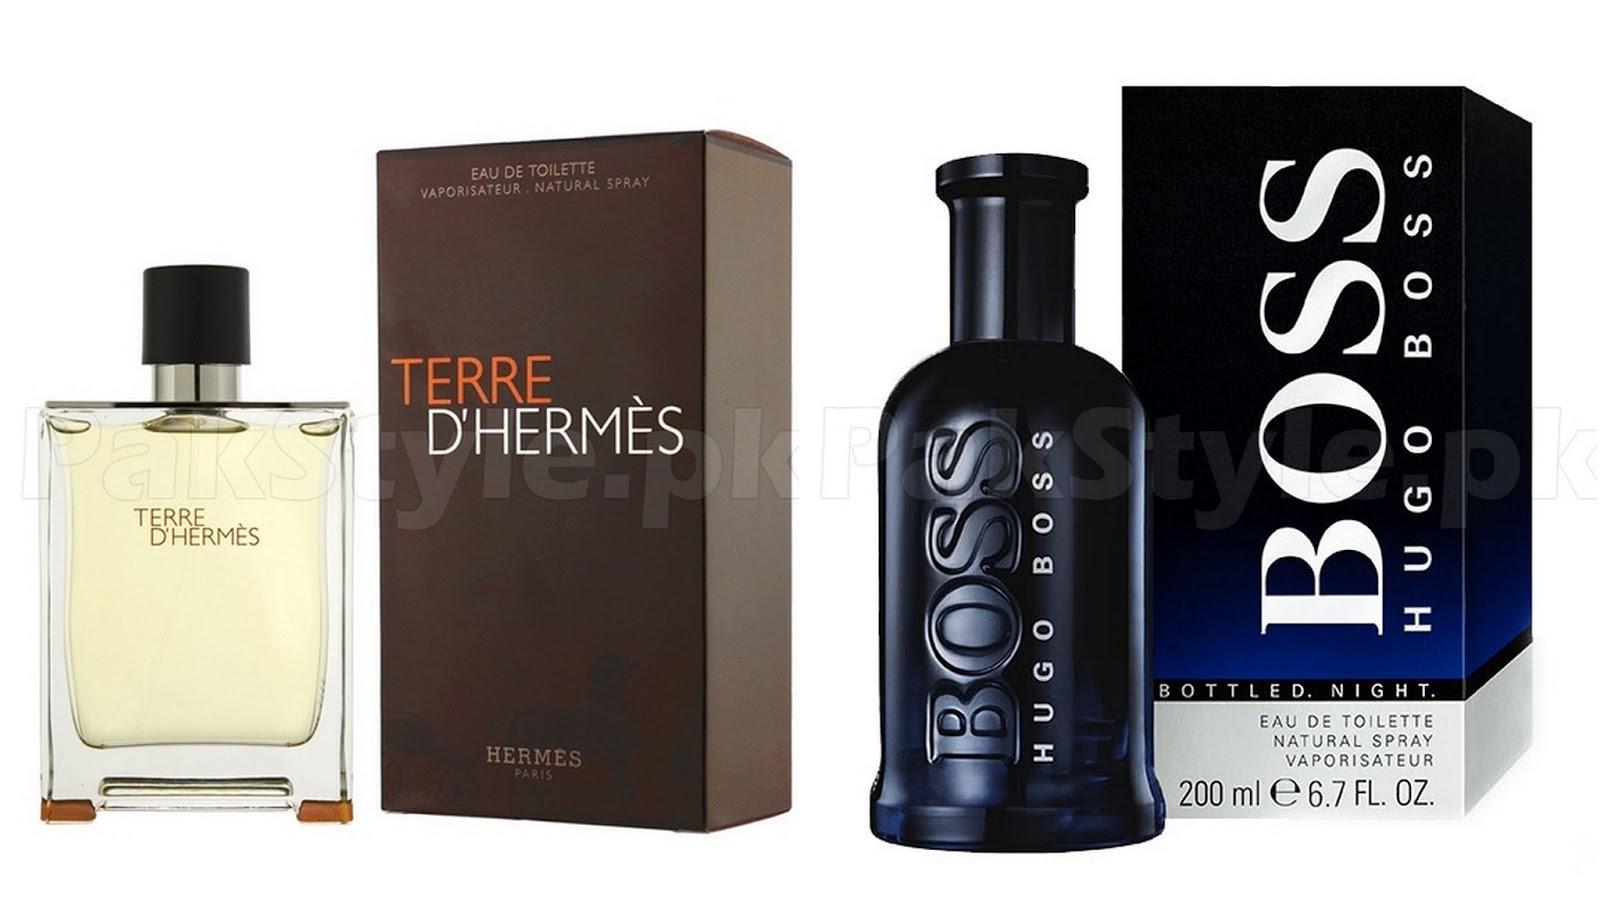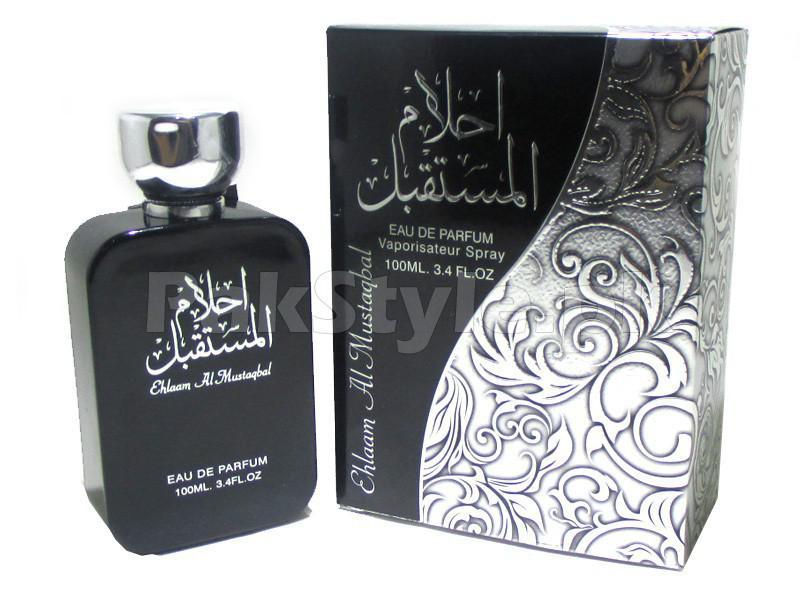The first image is the image on the left, the second image is the image on the right. Considering the images on both sides, is "There are more bottles of perfume with rounded edges than there are with sharp edges." valid? Answer yes or no. Yes. The first image is the image on the left, the second image is the image on the right. For the images displayed, is the sentence "A square bottle of pale yellowish liquid stands to the right and slightly overlapping its box." factually correct? Answer yes or no. No. 